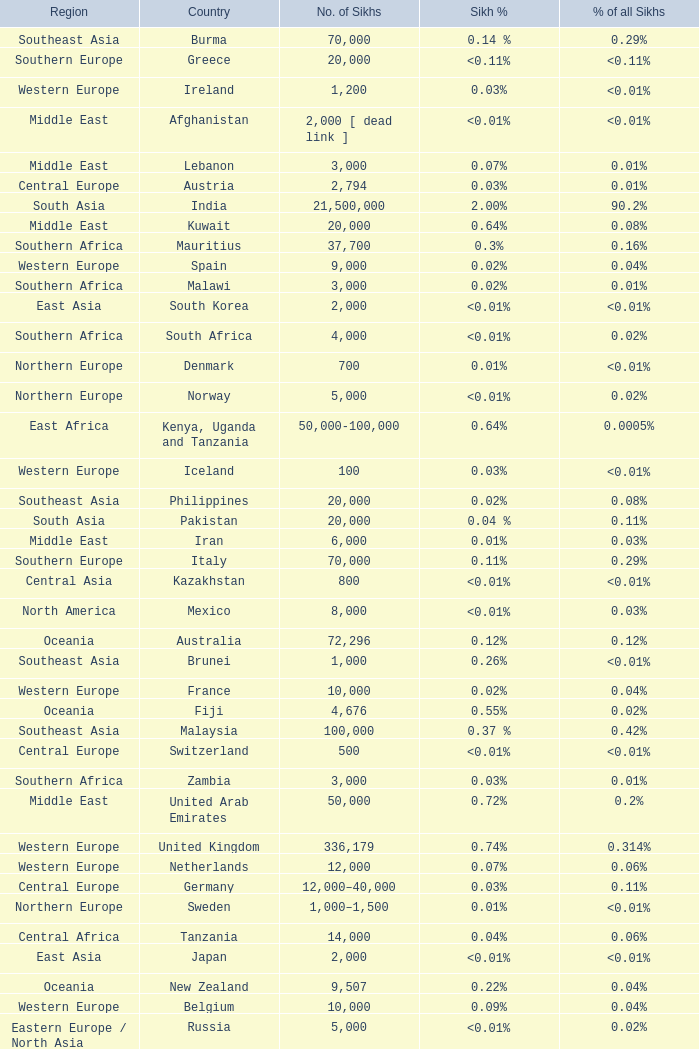What is the number of sikhs in Japan? 2000.0. 